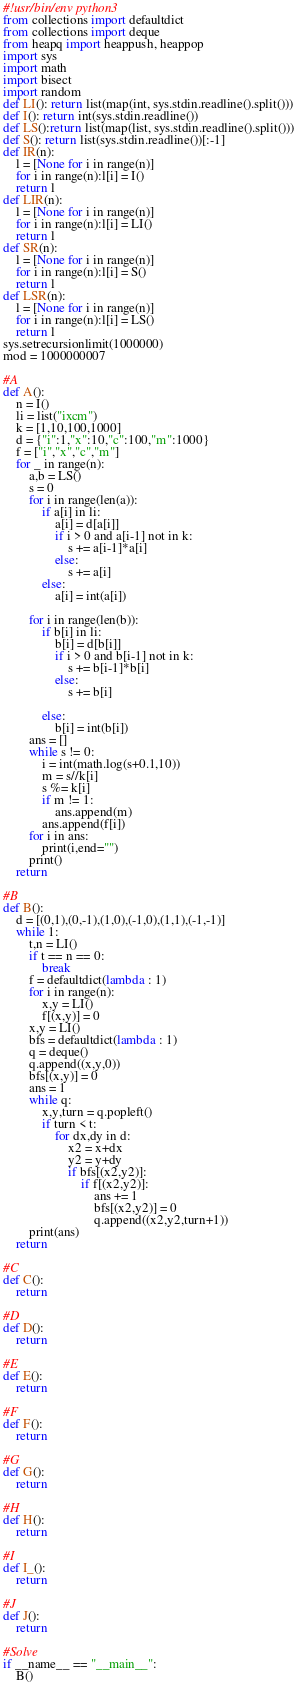<code> <loc_0><loc_0><loc_500><loc_500><_Python_>#!usr/bin/env python3
from collections import defaultdict
from collections import deque
from heapq import heappush, heappop
import sys
import math
import bisect
import random
def LI(): return list(map(int, sys.stdin.readline().split()))
def I(): return int(sys.stdin.readline())
def LS():return list(map(list, sys.stdin.readline().split()))
def S(): return list(sys.stdin.readline())[:-1]
def IR(n):
    l = [None for i in range(n)]
    for i in range(n):l[i] = I()
    return l
def LIR(n):
    l = [None for i in range(n)]
    for i in range(n):l[i] = LI()
    return l
def SR(n):
    l = [None for i in range(n)]
    for i in range(n):l[i] = S()
    return l
def LSR(n):
    l = [None for i in range(n)]
    for i in range(n):l[i] = LS()
    return l
sys.setrecursionlimit(1000000)
mod = 1000000007

#A
def A():
    n = I()
    li = list("ixcm")
    k = [1,10,100,1000]
    d = {"i":1,"x":10,"c":100,"m":1000}
    f = ["i","x","c","m"]
    for _ in range(n):
        a,b = LS()
        s = 0
        for i in range(len(a)):
            if a[i] in li:
                a[i] = d[a[i]]
                if i > 0 and a[i-1] not in k:
                    s += a[i-1]*a[i]
                else:
                    s += a[i]
            else:
                a[i] = int(a[i])

        for i in range(len(b)):
            if b[i] in li:
                b[i] = d[b[i]]
                if i > 0 and b[i-1] not in k:
                    s += b[i-1]*b[i]
                else:
                    s += b[i]

            else:
                b[i] = int(b[i])
        ans = []
        while s != 0:
            i = int(math.log(s+0.1,10))
            m = s//k[i]
            s %= k[i]
            if m != 1:
                ans.append(m)
            ans.append(f[i])
        for i in ans:
            print(i,end="")
        print()
    return

#B
def B():
    d = [(0,1),(0,-1),(1,0),(-1,0),(1,1),(-1,-1)]
    while 1:
        t,n = LI()
        if t == n == 0:
            break
        f = defaultdict(lambda : 1)
        for i in range(n):
            x,y = LI()
            f[(x,y)] = 0
        x,y = LI()
        bfs = defaultdict(lambda : 1)
        q = deque()
        q.append((x,y,0))
        bfs[(x,y)] = 0
        ans = 1
        while q:
            x,y,turn = q.popleft()
            if turn < t:
                for dx,dy in d:
                    x2 = x+dx
                    y2 = y+dy
                    if bfs[(x2,y2)]:
                        if f[(x2,y2)]:
                            ans += 1
                            bfs[(x2,y2)] = 0
                            q.append((x2,y2,turn+1))
        print(ans)
    return

#C
def C():
    return

#D
def D():
    return

#E
def E():
    return

#F
def F():
    return

#G
def G():
    return

#H
def H():
    return

#I
def I_():
    return

#J
def J():
    return

#Solve
if __name__ == "__main__":
    B()

</code> 